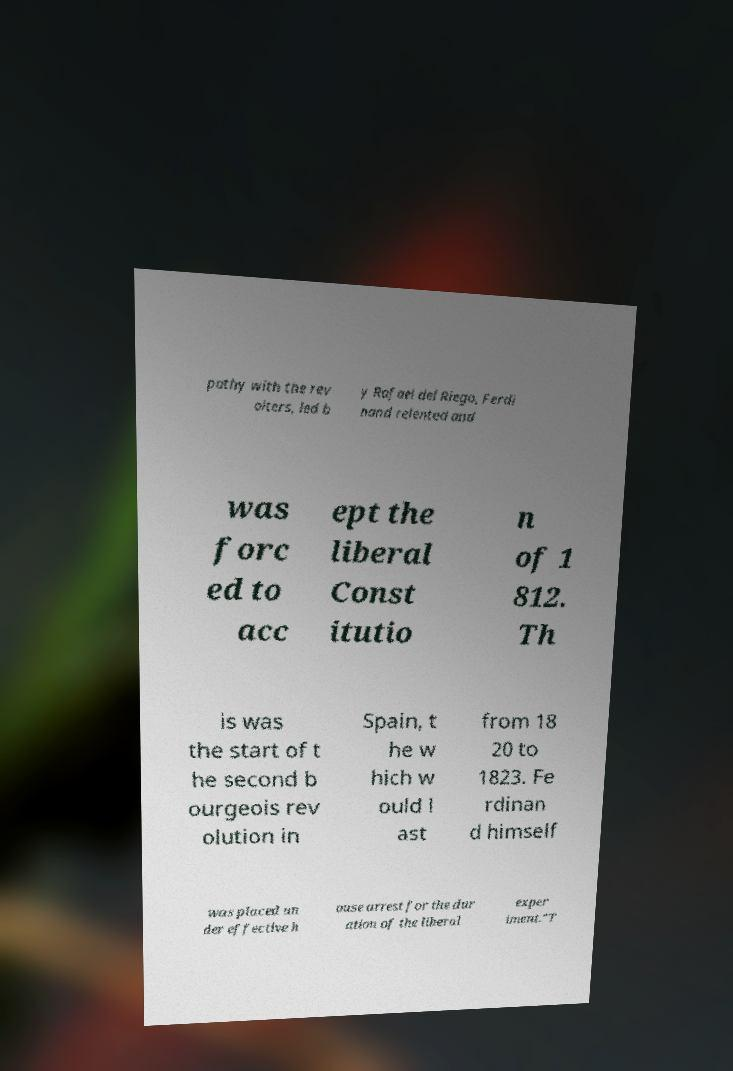Can you read and provide the text displayed in the image?This photo seems to have some interesting text. Can you extract and type it out for me? pathy with the rev olters, led b y Rafael del Riego, Ferdi nand relented and was forc ed to acc ept the liberal Const itutio n of 1 812. Th is was the start of t he second b ourgeois rev olution in Spain, t he w hich w ould l ast from 18 20 to 1823. Fe rdinan d himself was placed un der effective h ouse arrest for the dur ation of the liberal exper iment."T 